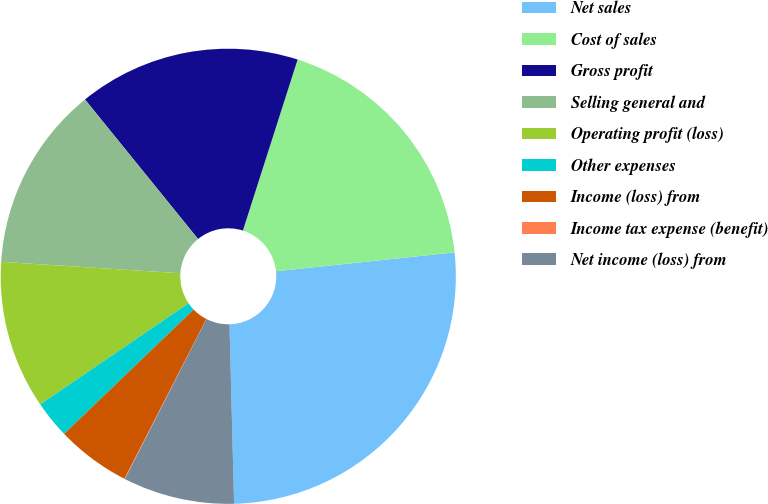Convert chart. <chart><loc_0><loc_0><loc_500><loc_500><pie_chart><fcel>Net sales<fcel>Cost of sales<fcel>Gross profit<fcel>Selling general and<fcel>Operating profit (loss)<fcel>Other expenses<fcel>Income (loss) from<fcel>Income tax expense (benefit)<fcel>Net income (loss) from<nl><fcel>26.27%<fcel>18.4%<fcel>15.77%<fcel>13.15%<fcel>10.53%<fcel>2.66%<fcel>5.28%<fcel>0.04%<fcel>7.91%<nl></chart> 